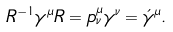<formula> <loc_0><loc_0><loc_500><loc_500>R ^ { - 1 } \gamma ^ { \mu } R = p ^ { \mu } _ { \nu } \gamma ^ { \nu } = \acute { \gamma } ^ { \mu } .</formula> 